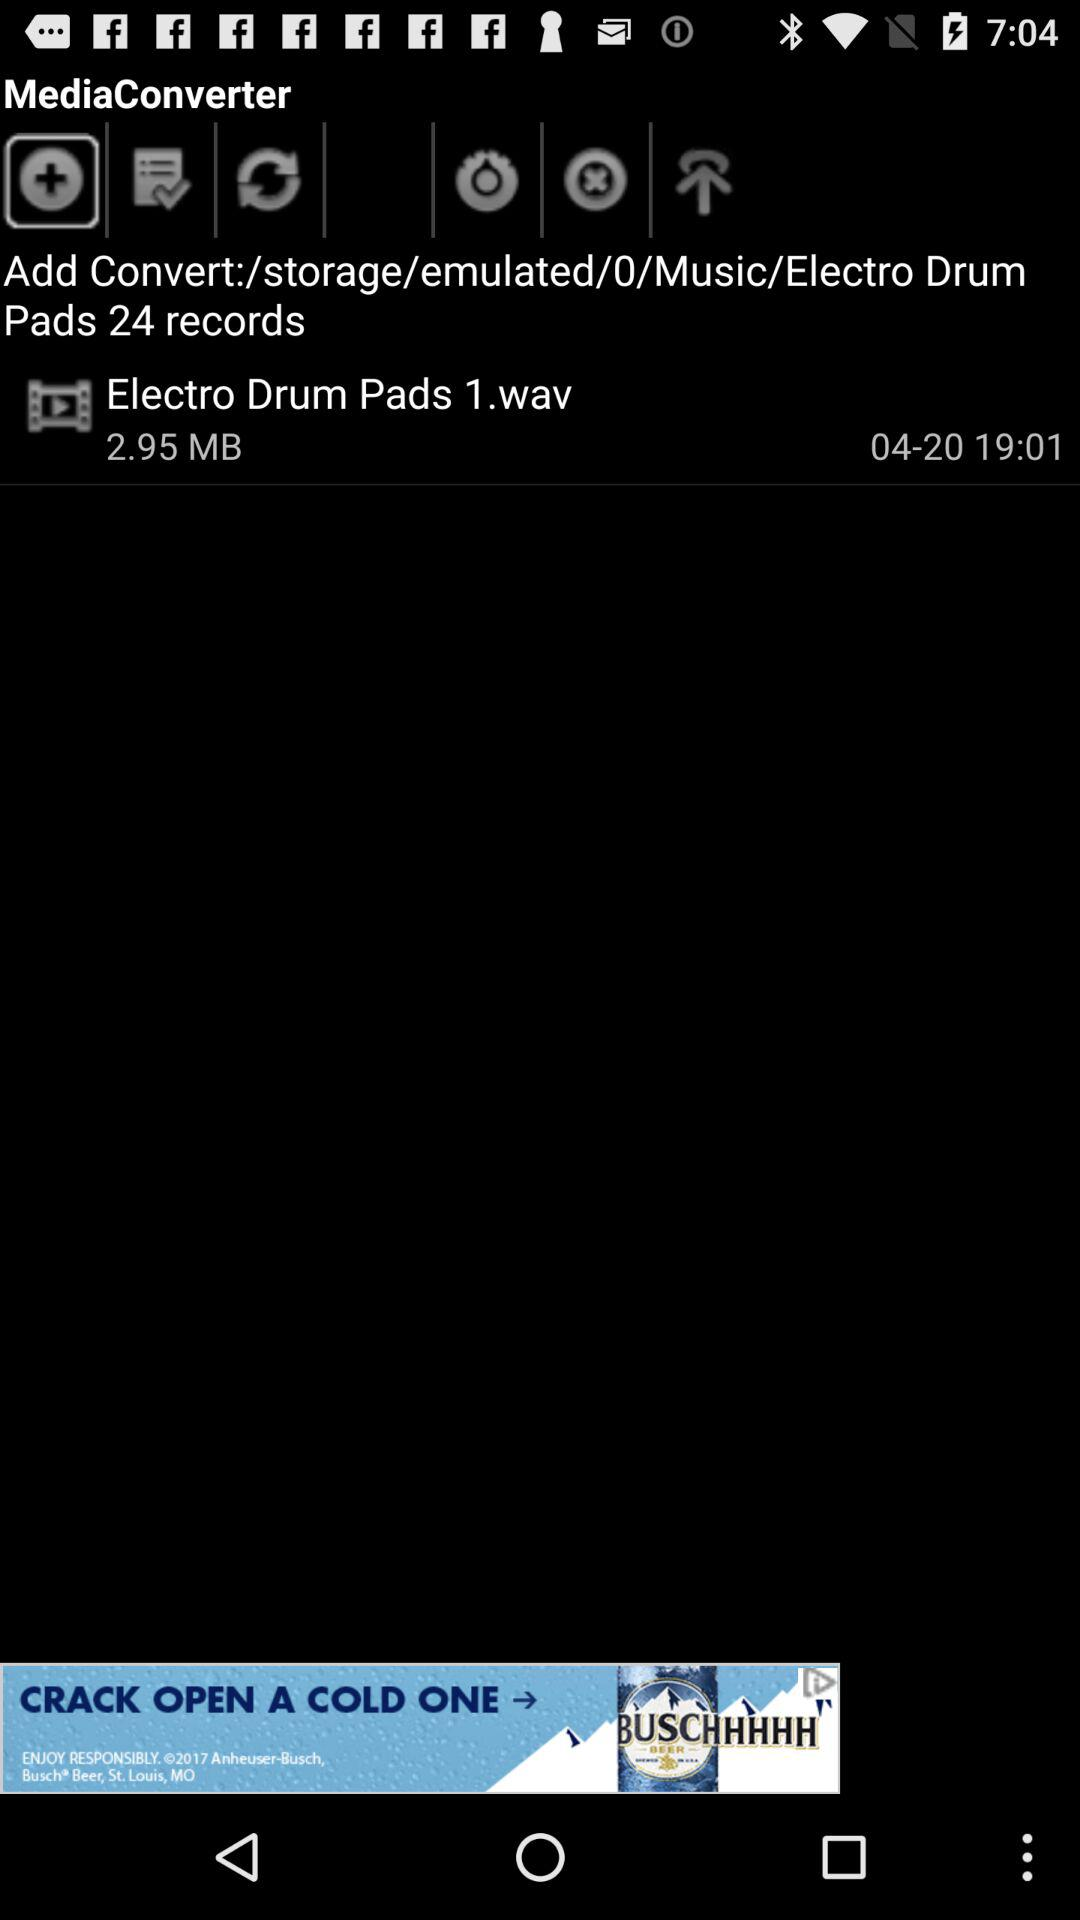How many MB is the file size of the audio file?
Answer the question using a single word or phrase. 2.95 